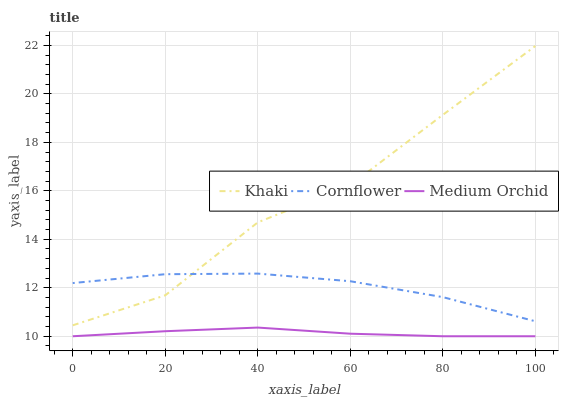Does Medium Orchid have the minimum area under the curve?
Answer yes or no. Yes. Does Khaki have the maximum area under the curve?
Answer yes or no. Yes. Does Khaki have the minimum area under the curve?
Answer yes or no. No. Does Medium Orchid have the maximum area under the curve?
Answer yes or no. No. Is Medium Orchid the smoothest?
Answer yes or no. Yes. Is Khaki the roughest?
Answer yes or no. Yes. Is Khaki the smoothest?
Answer yes or no. No. Is Medium Orchid the roughest?
Answer yes or no. No. Does Medium Orchid have the lowest value?
Answer yes or no. Yes. Does Khaki have the lowest value?
Answer yes or no. No. Does Khaki have the highest value?
Answer yes or no. Yes. Does Medium Orchid have the highest value?
Answer yes or no. No. Is Medium Orchid less than Cornflower?
Answer yes or no. Yes. Is Cornflower greater than Medium Orchid?
Answer yes or no. Yes. Does Khaki intersect Cornflower?
Answer yes or no. Yes. Is Khaki less than Cornflower?
Answer yes or no. No. Is Khaki greater than Cornflower?
Answer yes or no. No. Does Medium Orchid intersect Cornflower?
Answer yes or no. No. 